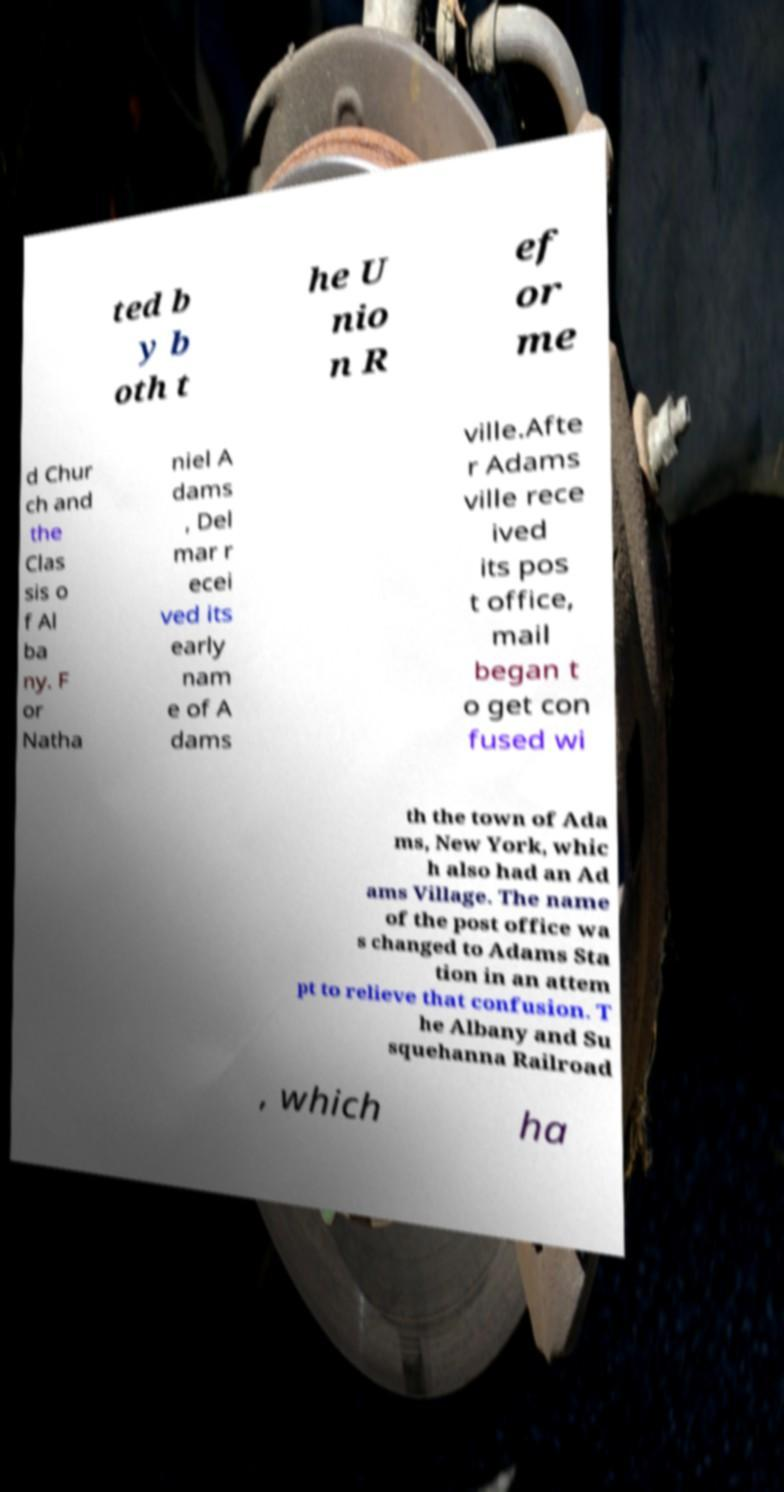Could you assist in decoding the text presented in this image and type it out clearly? ted b y b oth t he U nio n R ef or me d Chur ch and the Clas sis o f Al ba ny. F or Natha niel A dams , Del mar r ecei ved its early nam e of A dams ville.Afte r Adams ville rece ived its pos t office, mail began t o get con fused wi th the town of Ada ms, New York, whic h also had an Ad ams Village. The name of the post office wa s changed to Adams Sta tion in an attem pt to relieve that confusion. T he Albany and Su squehanna Railroad , which ha 